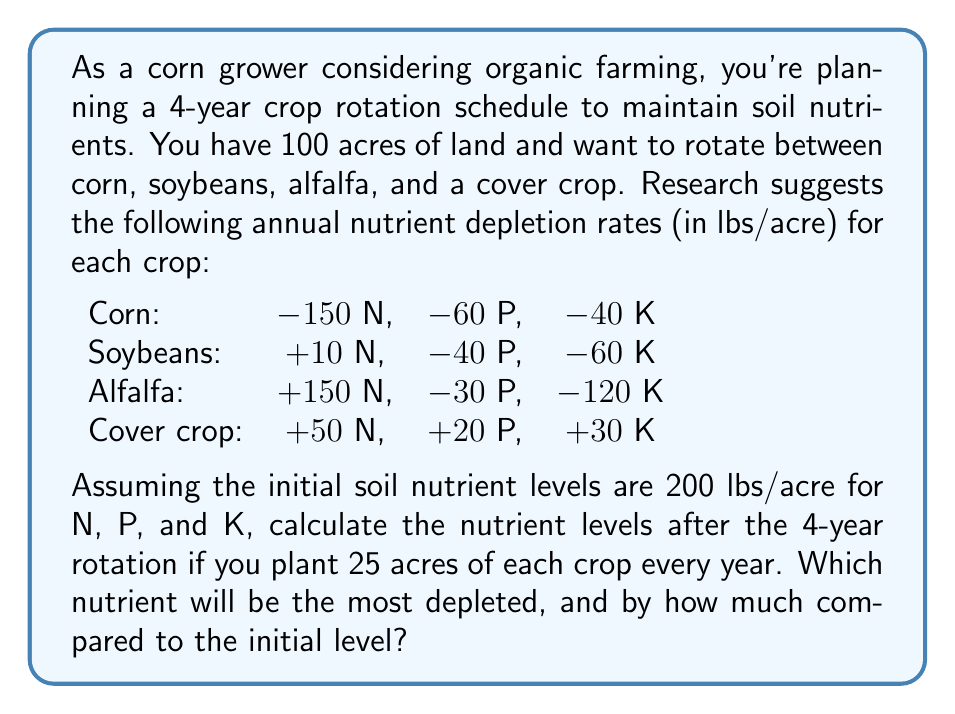Could you help me with this problem? Let's approach this problem step-by-step:

1) First, we need to calculate the total nutrient change over the 4-year period for each nutrient (N, P, K).

2) For each year, we'll have:
   25 acres of corn
   25 acres of soybeans
   25 acres of alfalfa
   25 acres of cover crop

3) Let's calculate the annual change for each nutrient:

   Nitrogen (N):
   $$(25 \times -150) + (25 \times 10) + (25 \times 150) + (25 \times 50) = 1500$$ lbs/year

   Phosphorus (P):
   $$(25 \times -60) + (25 \times -40) + (25 \times -30) + (25 \times 20) = -2750$$ lbs/year

   Potassium (K):
   $$(25 \times -40) + (25 \times -60) + (25 \times -120) + (25 \times 30) = -4750$$ lbs/year

4) Over 4 years, the total change will be:

   N: $1500 \times 4 = 6000$ lbs
   P: $-2750 \times 4 = -11000$ lbs
   K: $-4750 \times 4 = -19000$ lbs

5) The initial level for each nutrient was 200 lbs/acre over 100 acres, so 20,000 lbs total.

6) The final levels will be:

   N: $20000 + 6000 = 26000$ lbs
   P: $20000 - 11000 = 9000$ lbs
   K: $20000 - 19000 = 1000$ lbs

7) To find the most depleted nutrient, we compare the final levels to the initial:

   N: increased by 6000 lbs
   P: decreased by 11000 lbs
   K: decreased by 19000 lbs

Therefore, Potassium (K) is the most depleted nutrient.

8) The depletion of K compared to the initial level:
   $19000 / 20000 \times 100 = 95\%$
Answer: Potassium (K) will be the most depleted nutrient, reduced by 95% compared to the initial level. 